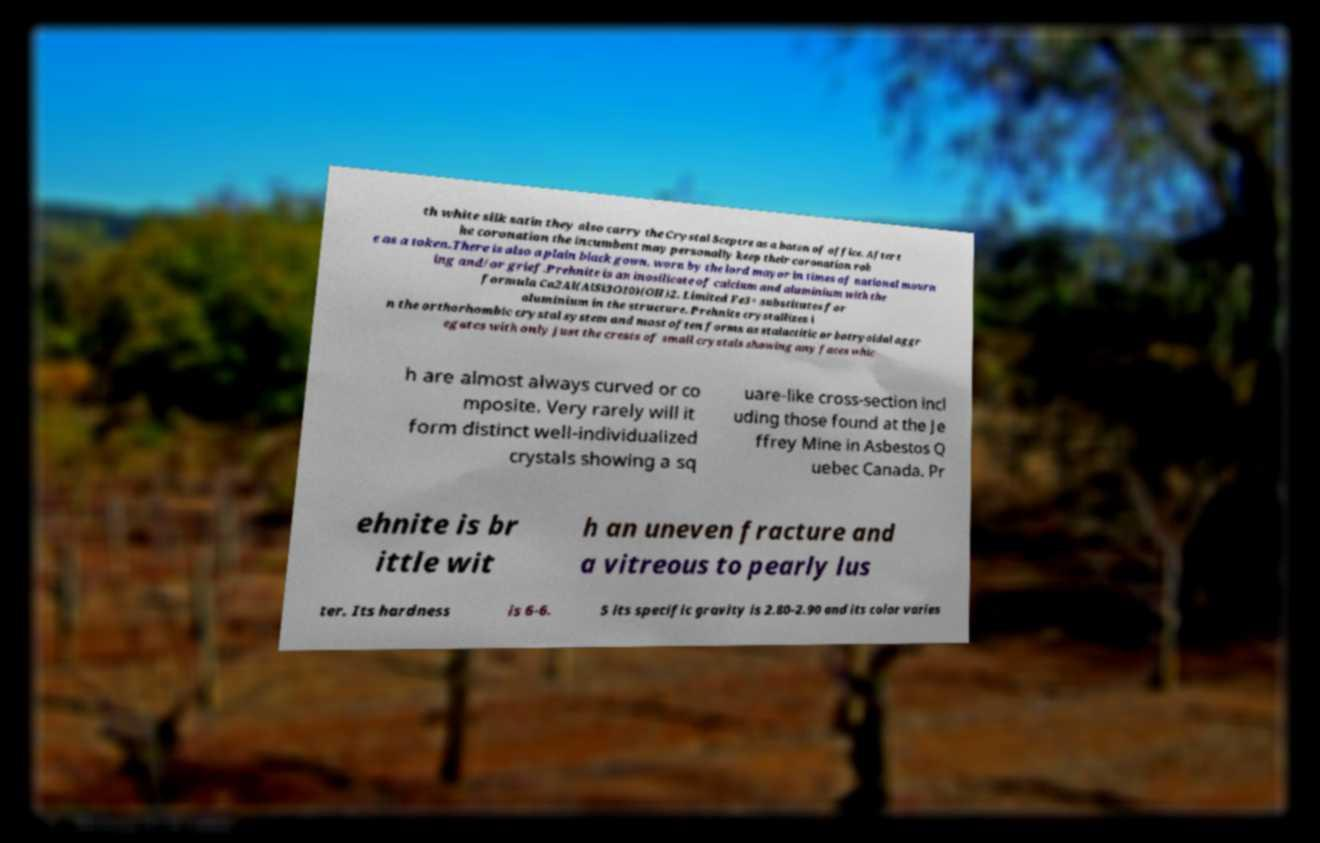There's text embedded in this image that I need extracted. Can you transcribe it verbatim? th white silk satin they also carry the Crystal Sceptre as a baton of office. After t he coronation the incumbent may personally keep their coronation rob e as a token.There is also a plain black gown, worn by the lord mayor in times of national mourn ing and/or grief.Prehnite is an inosilicate of calcium and aluminium with the formula Ca2Al(AlSi3O10)(OH)2. Limited Fe3+ substitutes for aluminium in the structure. Prehnite crystallizes i n the orthorhombic crystal system and most often forms as stalactitic or botryoidal aggr egates with only just the crests of small crystals showing any faces whic h are almost always curved or co mposite. Very rarely will it form distinct well-individualized crystals showing a sq uare-like cross-section incl uding those found at the Je ffrey Mine in Asbestos Q uebec Canada. Pr ehnite is br ittle wit h an uneven fracture and a vitreous to pearly lus ter. Its hardness is 6-6. 5 its specific gravity is 2.80-2.90 and its color varies 